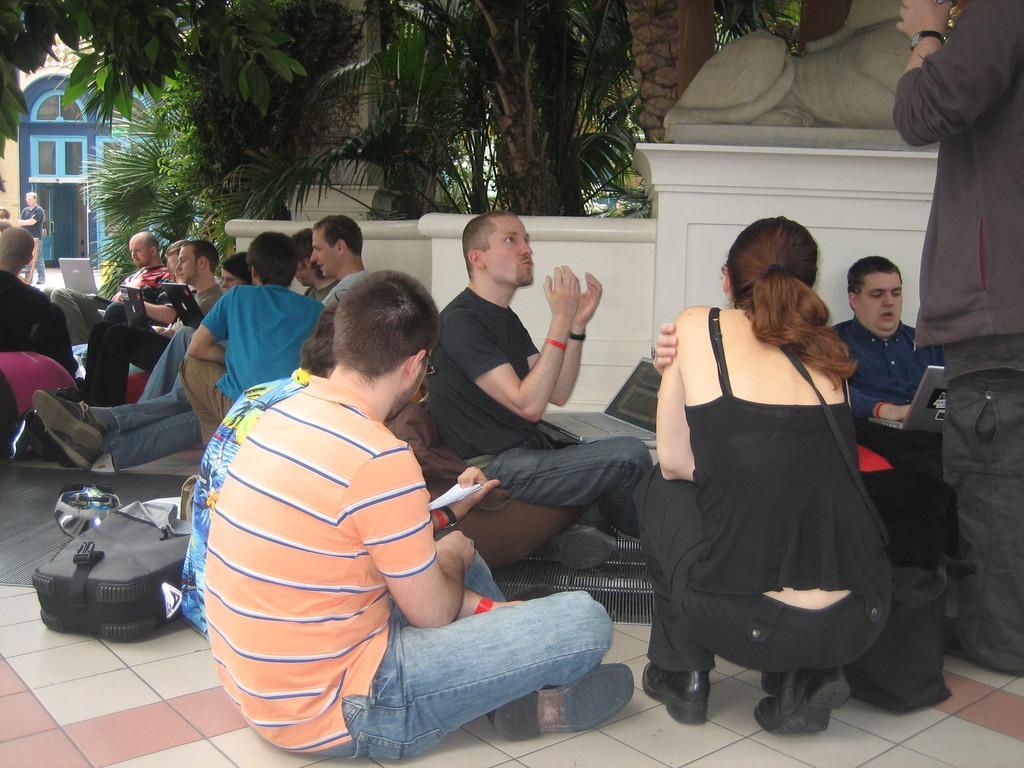In one or two sentences, can you explain what this image depicts? In this image there are group of people who are sitting, and some of them are holding laptops and some of them are holding books and some of them are talking. At the bottom there is floor, and on the floor there are some bags and in the background there is a building, plants, sculpture, wall and pillar. 